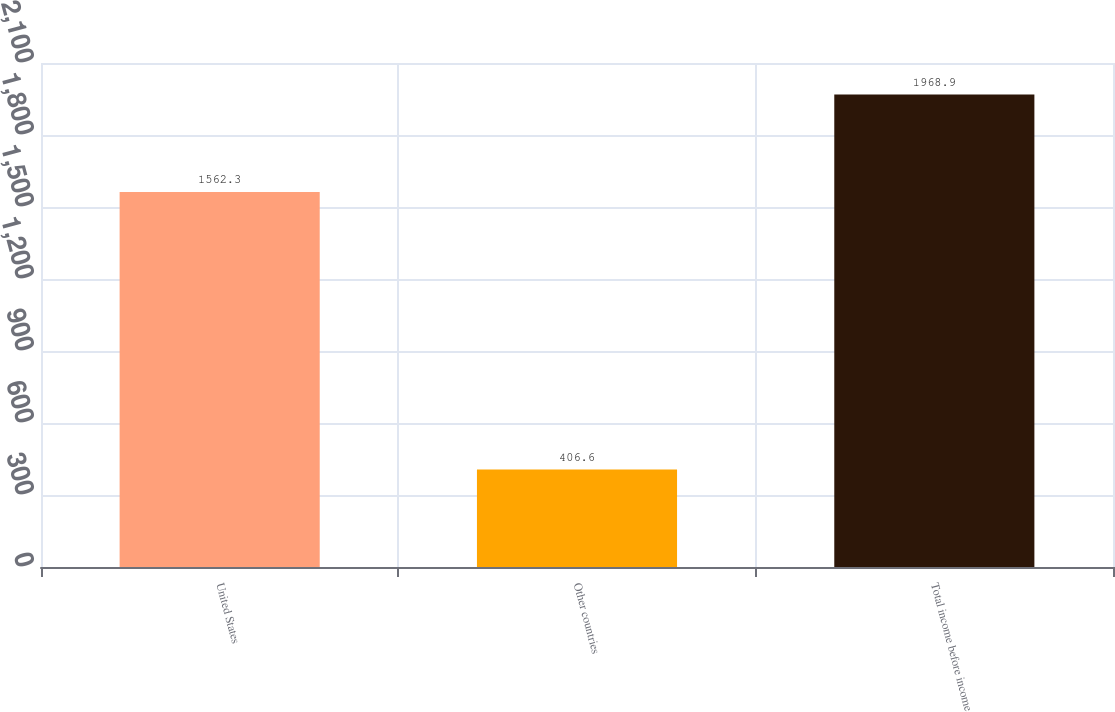Convert chart. <chart><loc_0><loc_0><loc_500><loc_500><bar_chart><fcel>United States<fcel>Other countries<fcel>Total income before income<nl><fcel>1562.3<fcel>406.6<fcel>1968.9<nl></chart> 